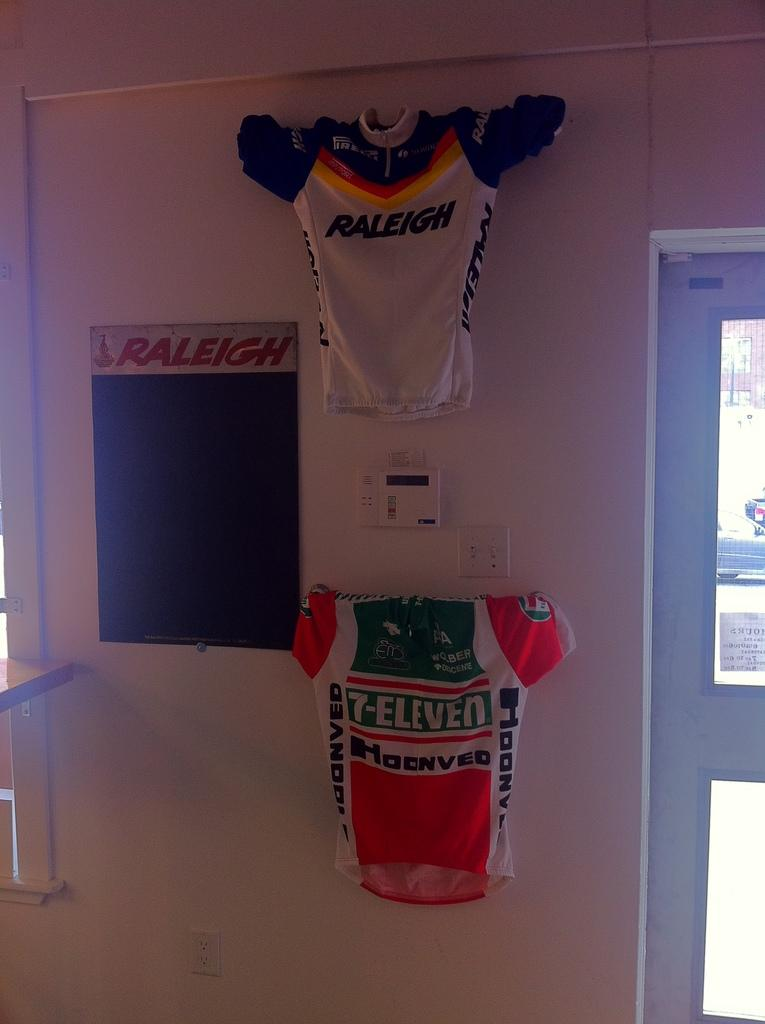<image>
Create a compact narrative representing the image presented. Two cycling shirts hang on a wall in a house and one has Raleigh on the front. 